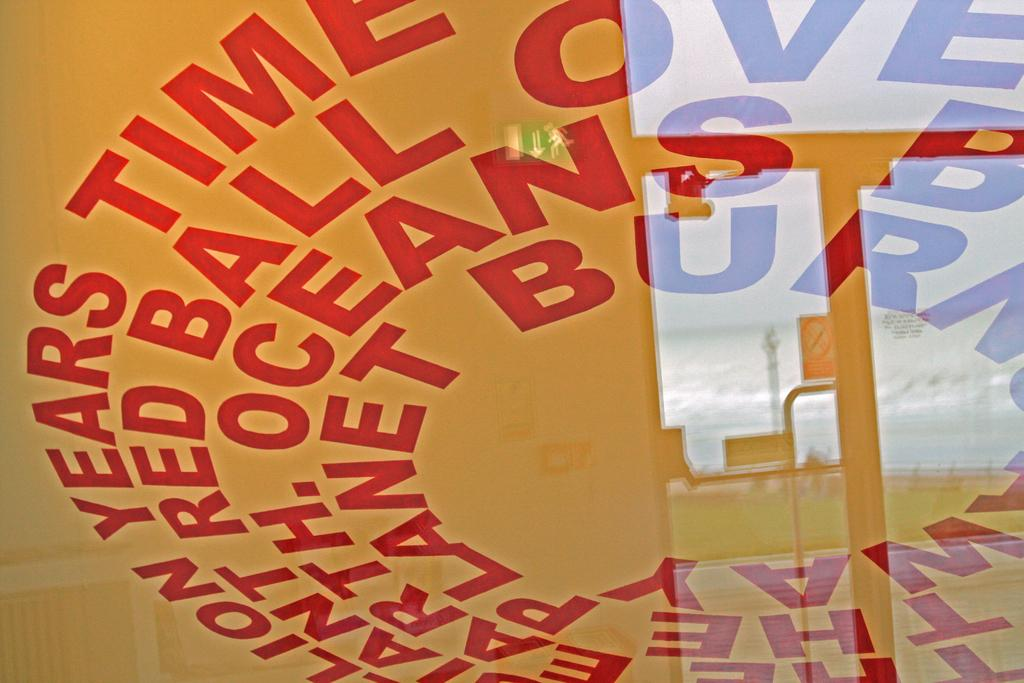What is the main object in the center of the image? There is a board in the center of the image. What can be seen on the board? There is text on the board. Where is the kitten playing with a toothbrush in the image? There is no kitten or toothbrush present in the image. What type of rat can be seen interacting with the text on the board? There is no rat present in the image; only the board and text are visible. 